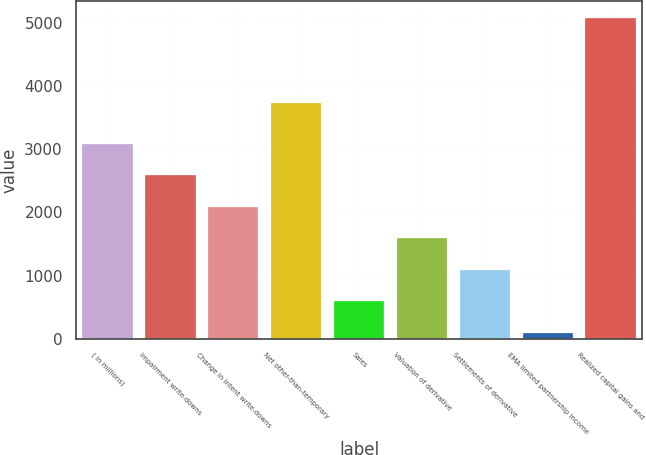Convert chart to OTSL. <chart><loc_0><loc_0><loc_500><loc_500><bar_chart><fcel>( in millions)<fcel>Impairment write-downs<fcel>Change in intent write-downs<fcel>Net other-than-temporary<fcel>Sales<fcel>Valuation of derivative<fcel>Settlements of derivative<fcel>EMA limited partnership income<fcel>Realized capital gains and<nl><fcel>3092.8<fcel>2593.5<fcel>2094.2<fcel>3735<fcel>596.3<fcel>1594.9<fcel>1095.6<fcel>97<fcel>5090<nl></chart> 